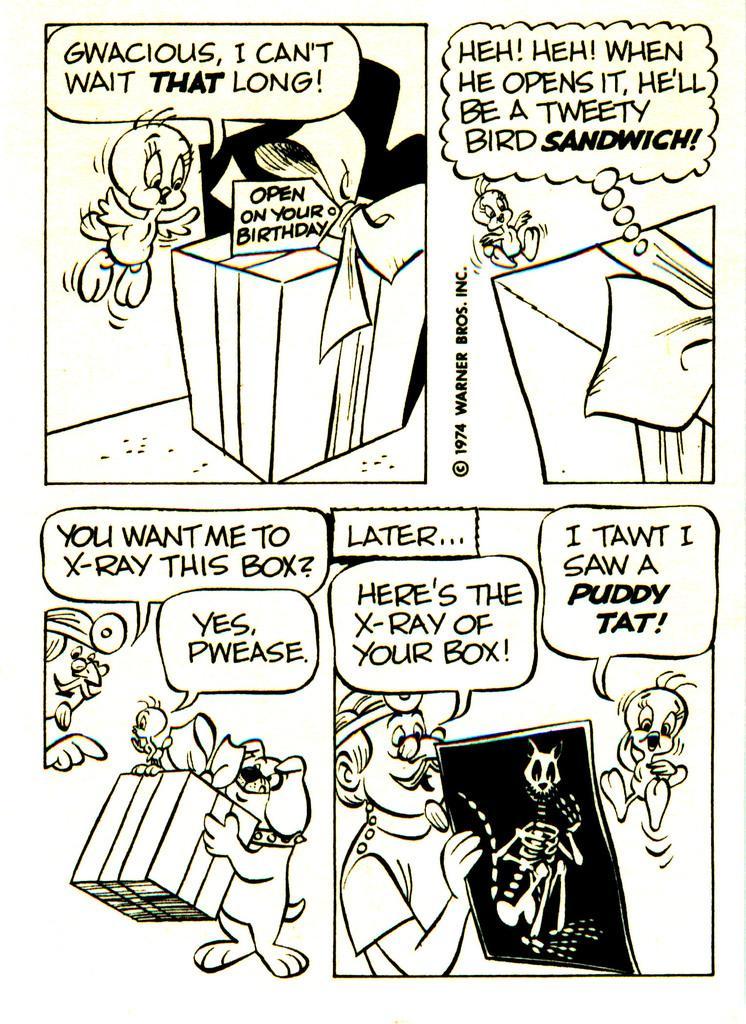How would you summarize this image in a sentence or two? In this image I can see an animated paintings of a person, dog, food, table and a text. 